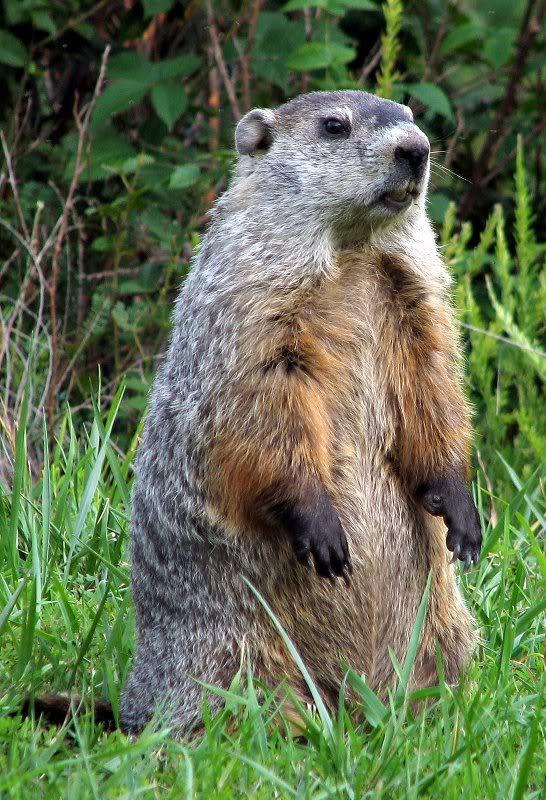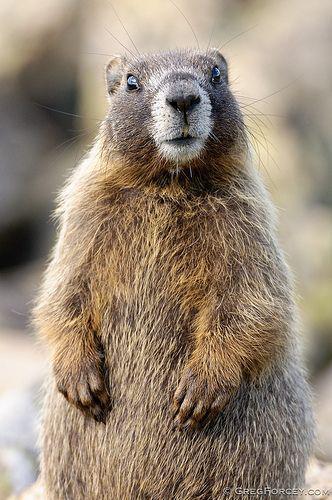The first image is the image on the left, the second image is the image on the right. Assess this claim about the two images: "Each image contains just one marmot, and marmots on the right and left have similar style poses with some paws visible.". Correct or not? Answer yes or no. Yes. The first image is the image on the left, the second image is the image on the right. Considering the images on both sides, is "At least two animals are on a rocky surface." valid? Answer yes or no. No. 